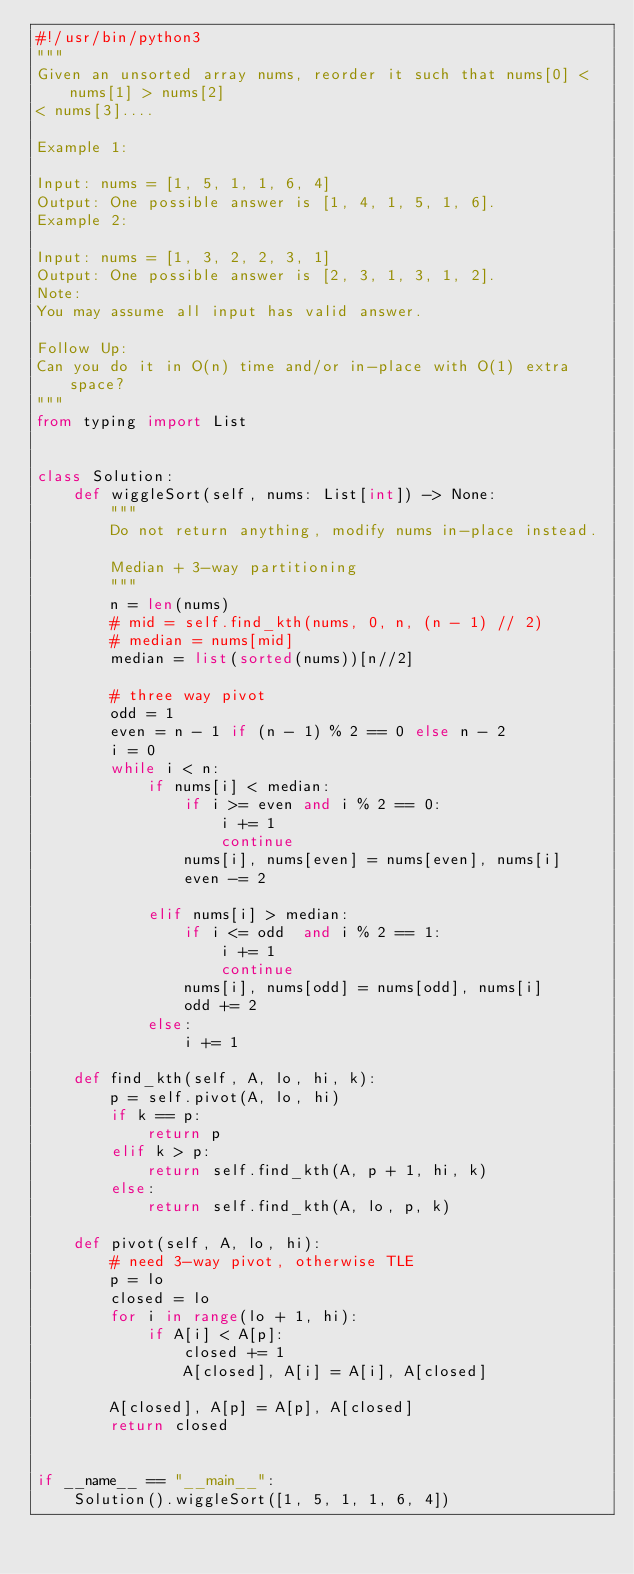Convert code to text. <code><loc_0><loc_0><loc_500><loc_500><_Python_>#!/usr/bin/python3
"""
Given an unsorted array nums, reorder it such that nums[0] < nums[1] > nums[2]
< nums[3]....

Example 1:

Input: nums = [1, 5, 1, 1, 6, 4]
Output: One possible answer is [1, 4, 1, 5, 1, 6].
Example 2:

Input: nums = [1, 3, 2, 2, 3, 1]
Output: One possible answer is [2, 3, 1, 3, 1, 2].
Note:
You may assume all input has valid answer.

Follow Up:
Can you do it in O(n) time and/or in-place with O(1) extra space?
"""
from typing import List


class Solution:
    def wiggleSort(self, nums: List[int]) -> None:
        """
        Do not return anything, modify nums in-place instead.

        Median + 3-way partitioning
        """
        n = len(nums)
        # mid = self.find_kth(nums, 0, n, (n - 1) // 2)
        # median = nums[mid]
        median = list(sorted(nums))[n//2]

        # three way pivot
        odd = 1
        even = n - 1 if (n - 1) % 2 == 0 else n - 2
        i = 0
        while i < n:
            if nums[i] < median:
                if i >= even and i % 2 == 0:
                    i += 1
                    continue
                nums[i], nums[even] = nums[even], nums[i]
                even -= 2

            elif nums[i] > median:
                if i <= odd  and i % 2 == 1:
                    i += 1
                    continue
                nums[i], nums[odd] = nums[odd], nums[i]
                odd += 2
            else:
                i += 1

    def find_kth(self, A, lo, hi, k):
        p = self.pivot(A, lo, hi)
        if k == p:
            return p
        elif k > p:
            return self.find_kth(A, p + 1, hi, k)
        else:
            return self.find_kth(A, lo, p, k)

    def pivot(self, A, lo, hi):
        # need 3-way pivot, otherwise TLE
        p = lo
        closed = lo
        for i in range(lo + 1, hi):
            if A[i] < A[p]:
                closed += 1
                A[closed], A[i] = A[i], A[closed]

        A[closed], A[p] = A[p], A[closed]
        return closed


if __name__ == "__main__":
    Solution().wiggleSort([1, 5, 1, 1, 6, 4])
</code> 